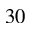<formula> <loc_0><loc_0><loc_500><loc_500>3 0</formula> 